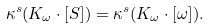Convert formula to latex. <formula><loc_0><loc_0><loc_500><loc_500>\kappa ^ { s } ( K _ { \omega } \cdot [ S ] ) = \kappa ^ { s } ( K _ { \omega } \cdot [ \omega ] ) .</formula> 